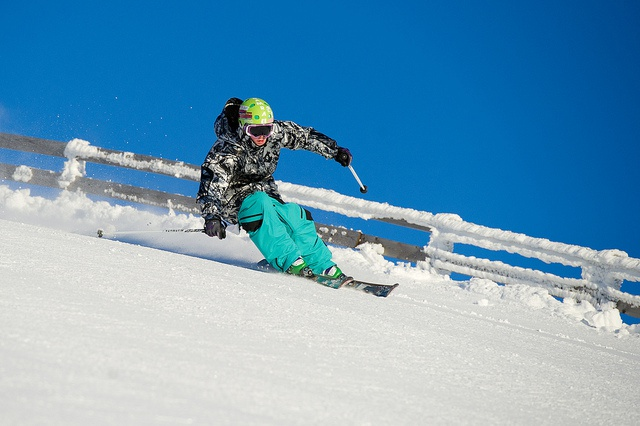Describe the objects in this image and their specific colors. I can see people in blue, black, turquoise, gray, and darkgray tones and snowboard in blue, gray, darkgray, teal, and lightgray tones in this image. 